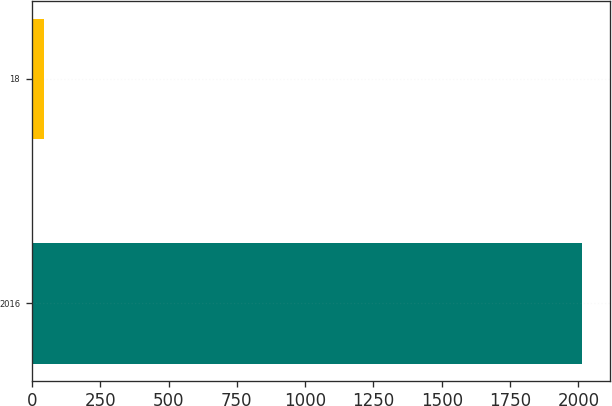<chart> <loc_0><loc_0><loc_500><loc_500><bar_chart><fcel>2016<fcel>18<nl><fcel>2014<fcel>43<nl></chart> 